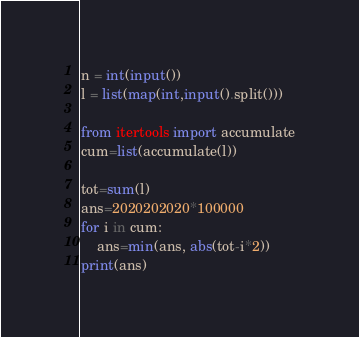Convert code to text. <code><loc_0><loc_0><loc_500><loc_500><_Python_>n = int(input())
l = list(map(int,input().split()))

from itertools import accumulate
cum=list(accumulate(l))

tot=sum(l)
ans=2020202020*100000
for i in cum:
    ans=min(ans, abs(tot-i*2))
print(ans)
</code> 